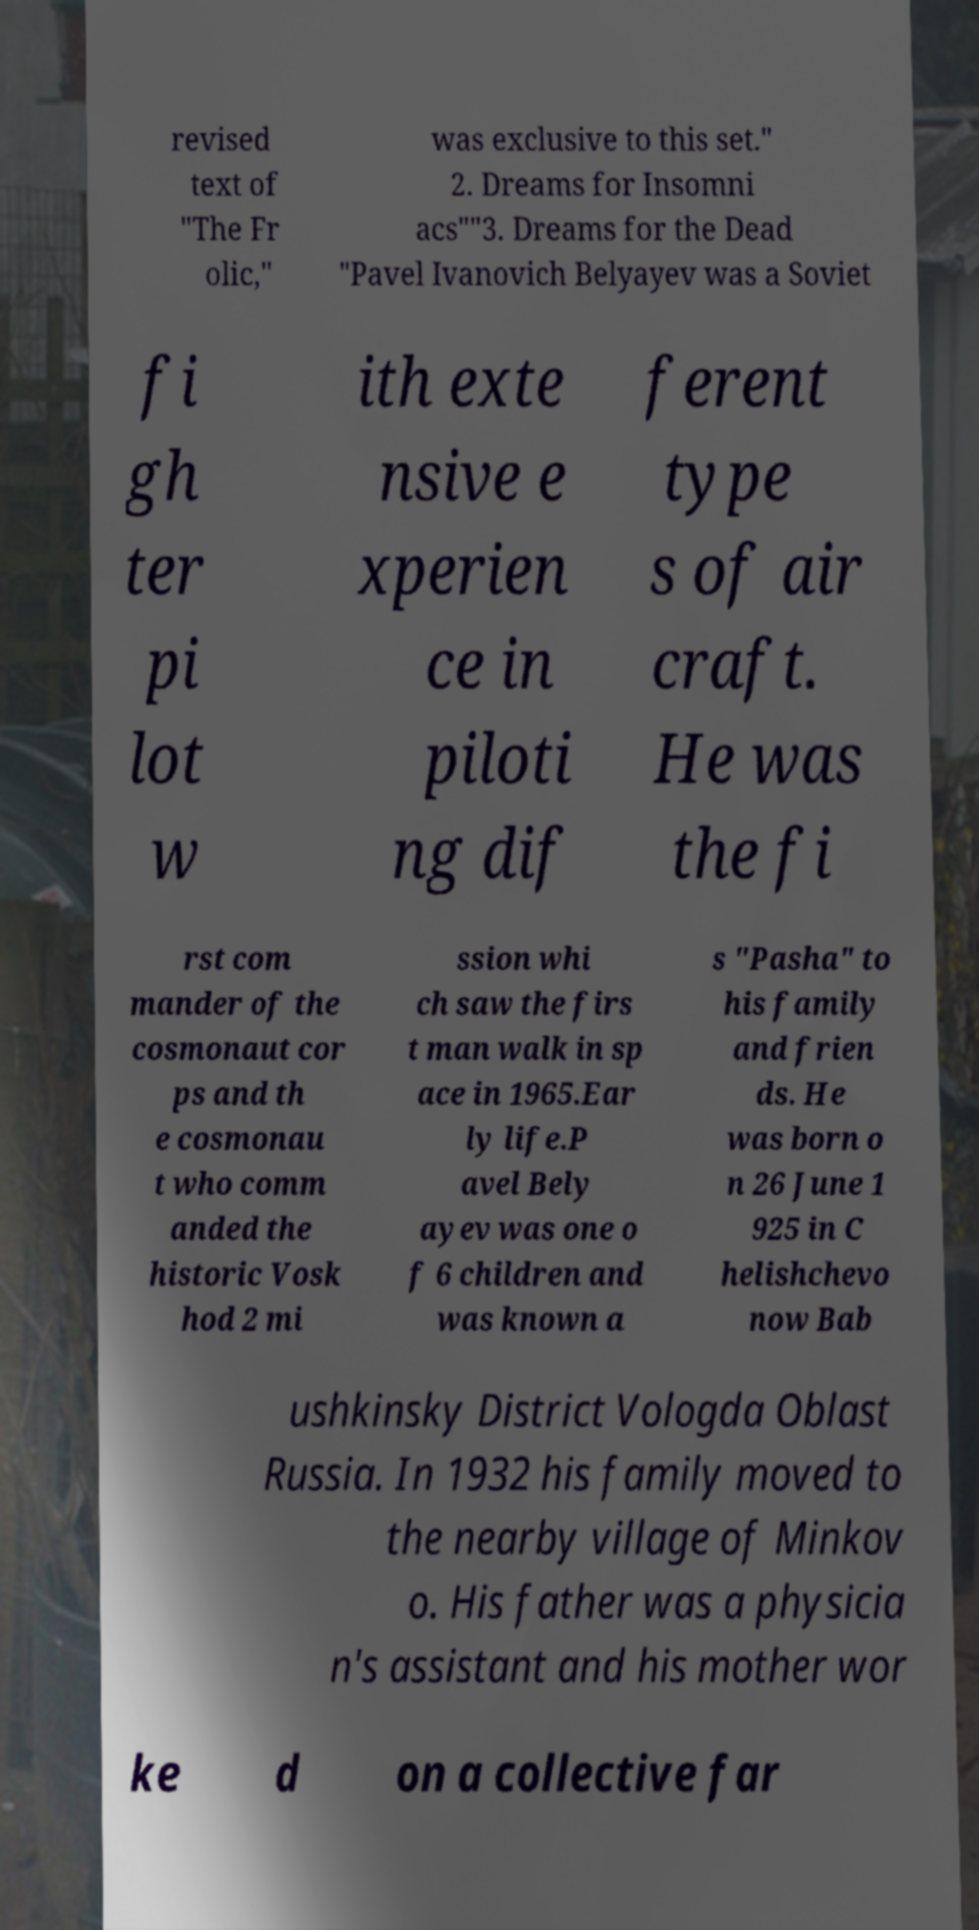What messages or text are displayed in this image? I need them in a readable, typed format. revised text of "The Fr olic," was exclusive to this set." 2. Dreams for Insomni acs""3. Dreams for the Dead "Pavel Ivanovich Belyayev was a Soviet fi gh ter pi lot w ith exte nsive e xperien ce in piloti ng dif ferent type s of air craft. He was the fi rst com mander of the cosmonaut cor ps and th e cosmonau t who comm anded the historic Vosk hod 2 mi ssion whi ch saw the firs t man walk in sp ace in 1965.Ear ly life.P avel Bely ayev was one o f 6 children and was known a s "Pasha" to his family and frien ds. He was born o n 26 June 1 925 in C helishchevo now Bab ushkinsky District Vologda Oblast Russia. In 1932 his family moved to the nearby village of Minkov o. His father was a physicia n's assistant and his mother wor ke d on a collective far 